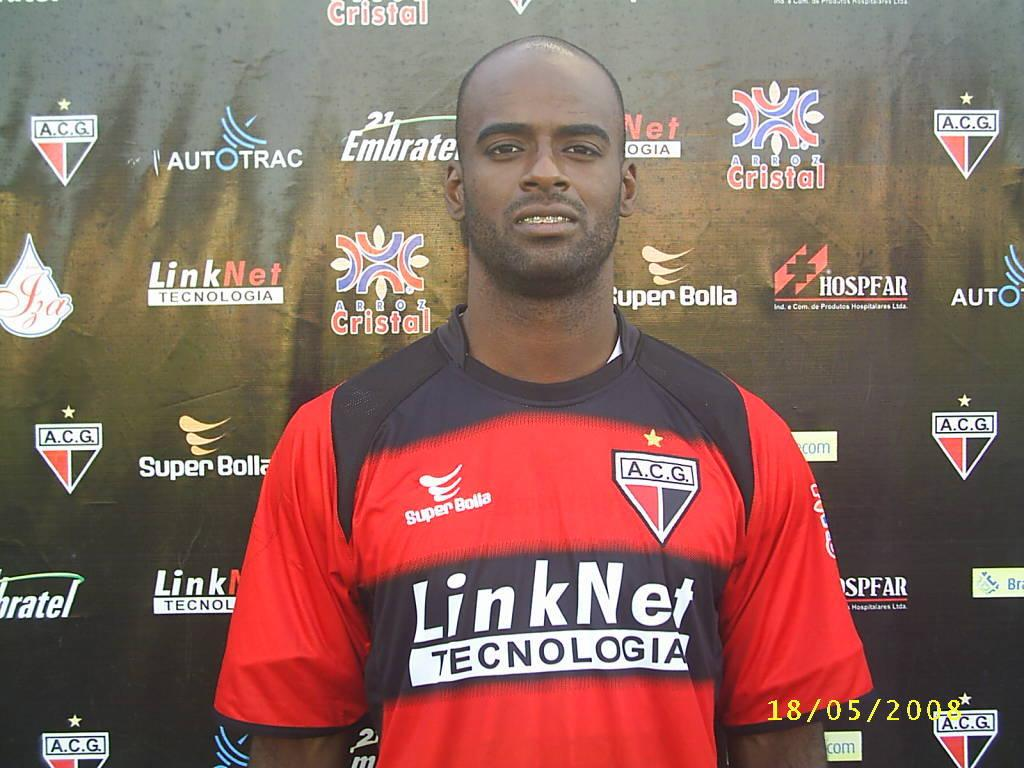Provide a one-sentence caption for the provided image. athlete posing with sponsors backdrop, Link Net Technolgia on the shirt. 